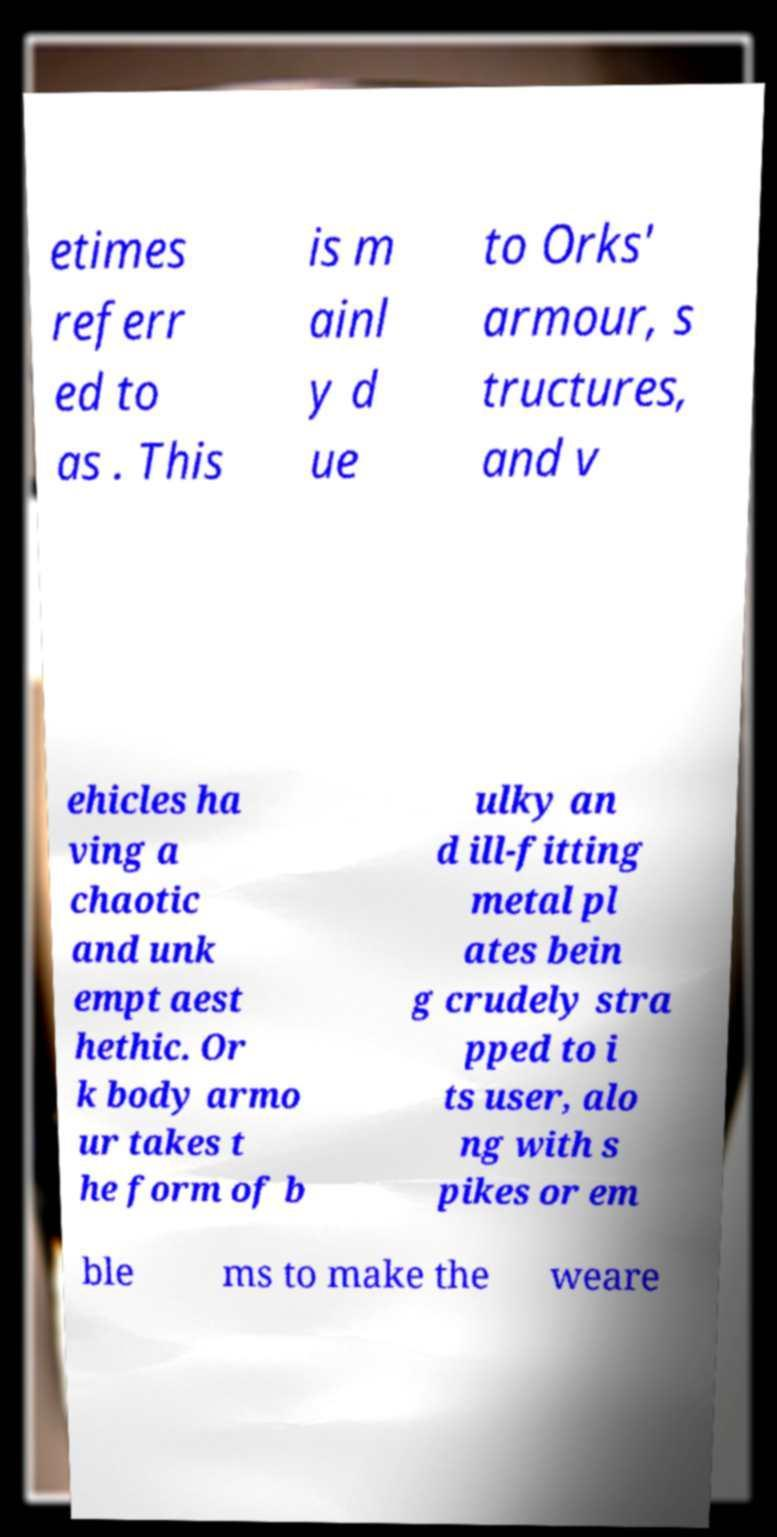For documentation purposes, I need the text within this image transcribed. Could you provide that? etimes referr ed to as . This is m ainl y d ue to Orks' armour, s tructures, and v ehicles ha ving a chaotic and unk empt aest hethic. Or k body armo ur takes t he form of b ulky an d ill-fitting metal pl ates bein g crudely stra pped to i ts user, alo ng with s pikes or em ble ms to make the weare 